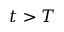<formula> <loc_0><loc_0><loc_500><loc_500>t > T</formula> 